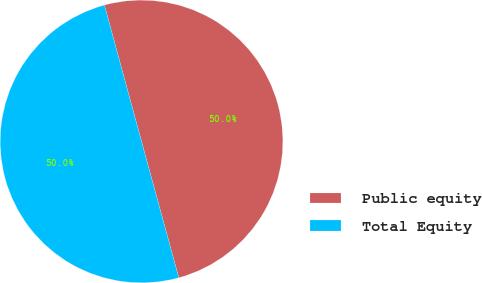Convert chart. <chart><loc_0><loc_0><loc_500><loc_500><pie_chart><fcel>Public equity<fcel>Total Equity<nl><fcel>49.98%<fcel>50.02%<nl></chart> 